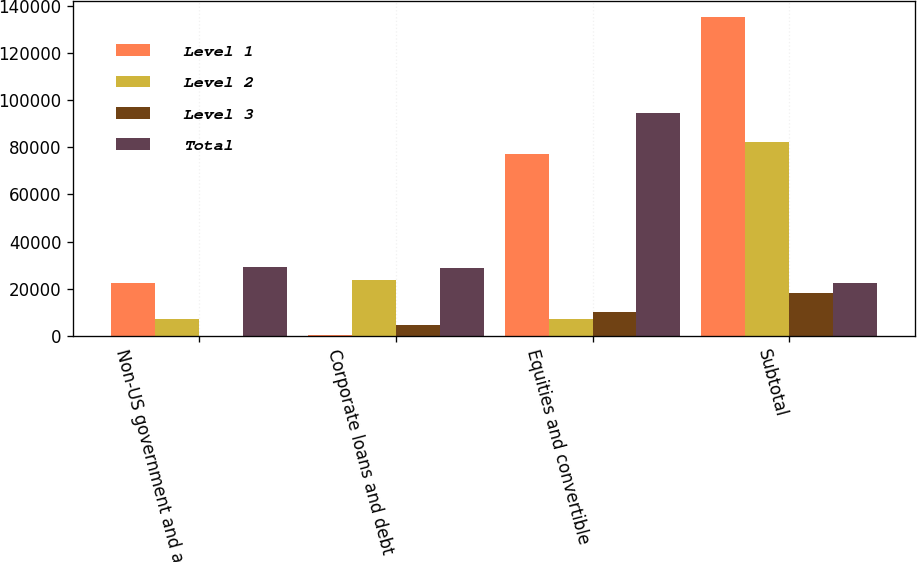Convert chart to OTSL. <chart><loc_0><loc_0><loc_500><loc_500><stacked_bar_chart><ecel><fcel>Non-US government and agency<fcel>Corporate loans and debt<fcel>Equities and convertible<fcel>Subtotal<nl><fcel>Level 1<fcel>22433<fcel>215<fcel>77276<fcel>135366<nl><fcel>Level 2<fcel>6933<fcel>23804<fcel>7153<fcel>82414<nl><fcel>Level 3<fcel>15<fcel>4640<fcel>10263<fcel>18035<nl><fcel>Total<fcel>29381<fcel>28659<fcel>94692<fcel>22433<nl></chart> 